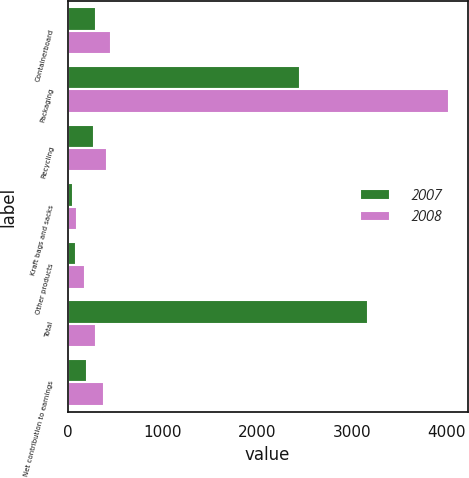Convert chart to OTSL. <chart><loc_0><loc_0><loc_500><loc_500><stacked_bar_chart><ecel><fcel>Containerboard<fcel>Packaging<fcel>Recycling<fcel>Kraft bags and sacks<fcel>Other products<fcel>Total<fcel>Net contribution to earnings<nl><fcel>2007<fcel>301<fcel>2449<fcel>275<fcel>56<fcel>88<fcel>3169<fcel>204<nl><fcel>2008<fcel>457<fcel>4019<fcel>413<fcel>96<fcel>183<fcel>301<fcel>382<nl></chart> 